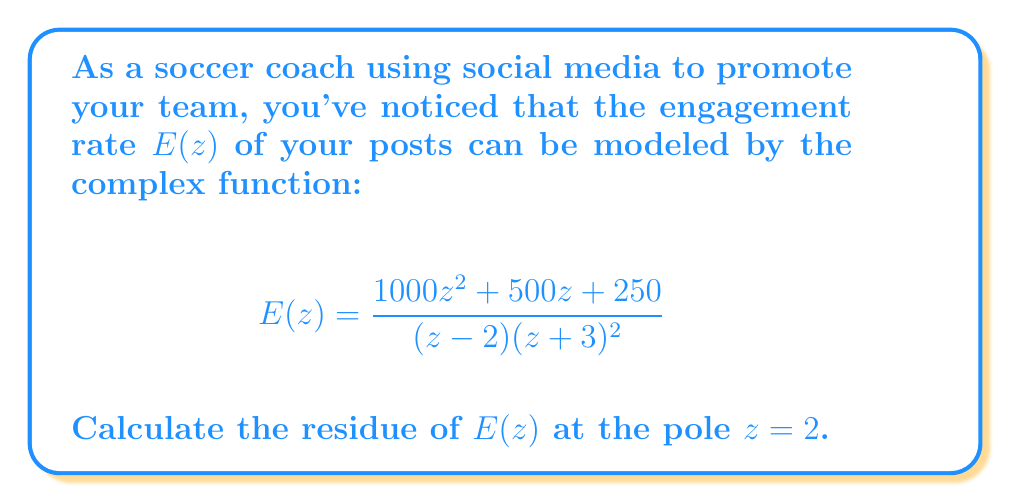Can you answer this question? To calculate the residue at $z = 2$, we follow these steps:

1) First, we identify that $z = 2$ is a simple pole (order 1) of $E(z)$.

2) For a simple pole, we can use the formula:
   $$\text{Res}(E, 2) = \lim_{z \to 2} (z-2)E(z)$$

3) Let's substitute the function:
   $$\text{Res}(E, 2) = \lim_{z \to 2} (z-2)\frac{1000z^2 + 500z + 250}{(z - 2)(z + 3)^2}$$

4) The $(z-2)$ terms cancel out:
   $$\text{Res}(E, 2) = \lim_{z \to 2} \frac{1000z^2 + 500z + 250}{(z + 3)^2}$$

5) Now we can directly substitute $z = 2$:
   $$\text{Res}(E, 2) = \frac{1000(2)^2 + 500(2) + 250}{(2 + 3)^2}$$

6) Simplify:
   $$\text{Res}(E, 2) = \frac{4000 + 1000 + 250}{25} = \frac{5250}{25} = 210$$

Therefore, the residue of $E(z)$ at $z = 2$ is 210.
Answer: $210$ 